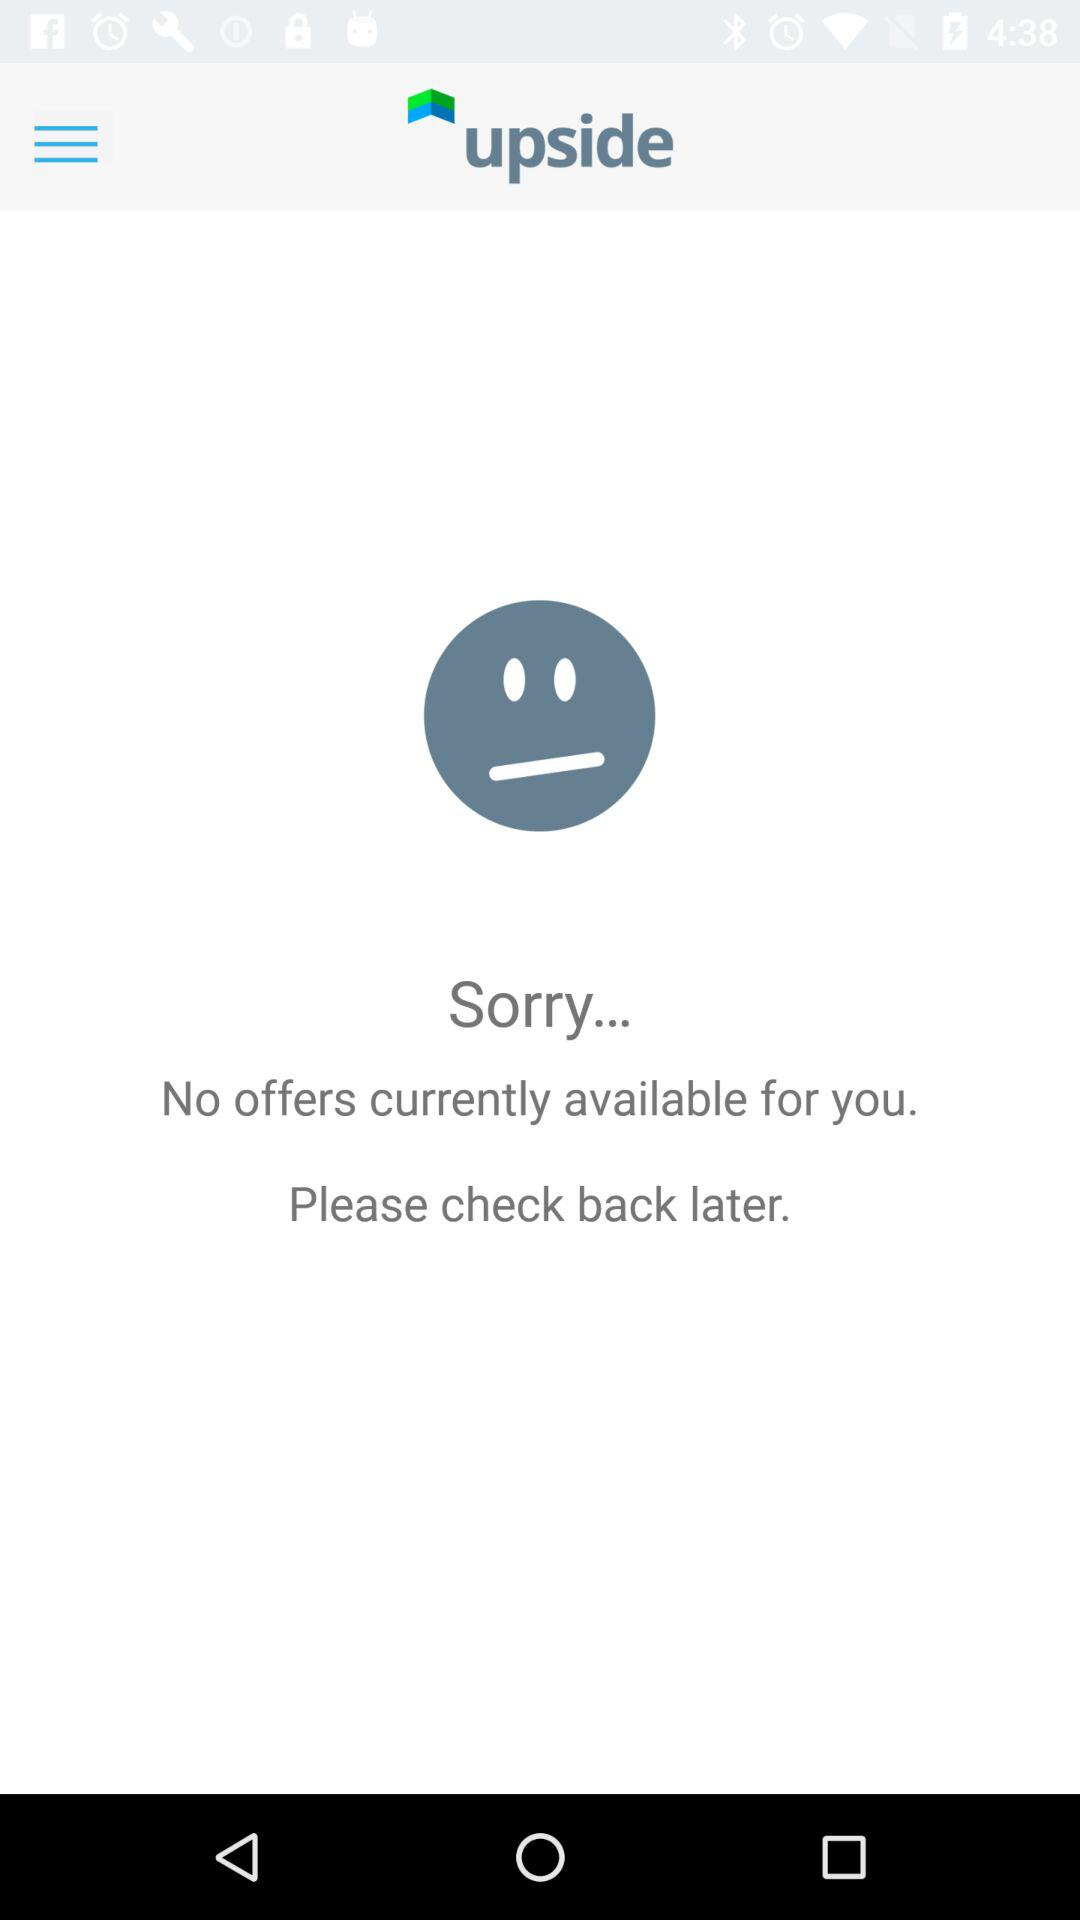What is the name of the application? The application name is "upside". 